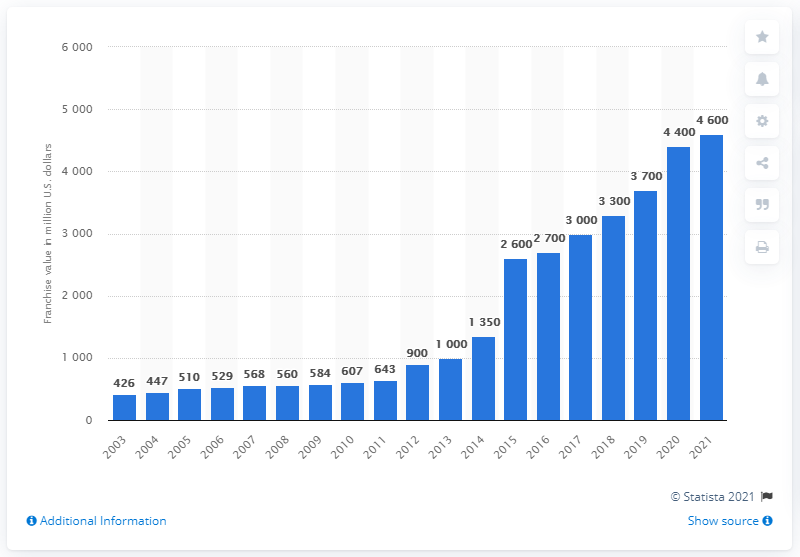Highlight a few significant elements in this photo. The estimated value of the Los Angeles Lakers is 4,600. 